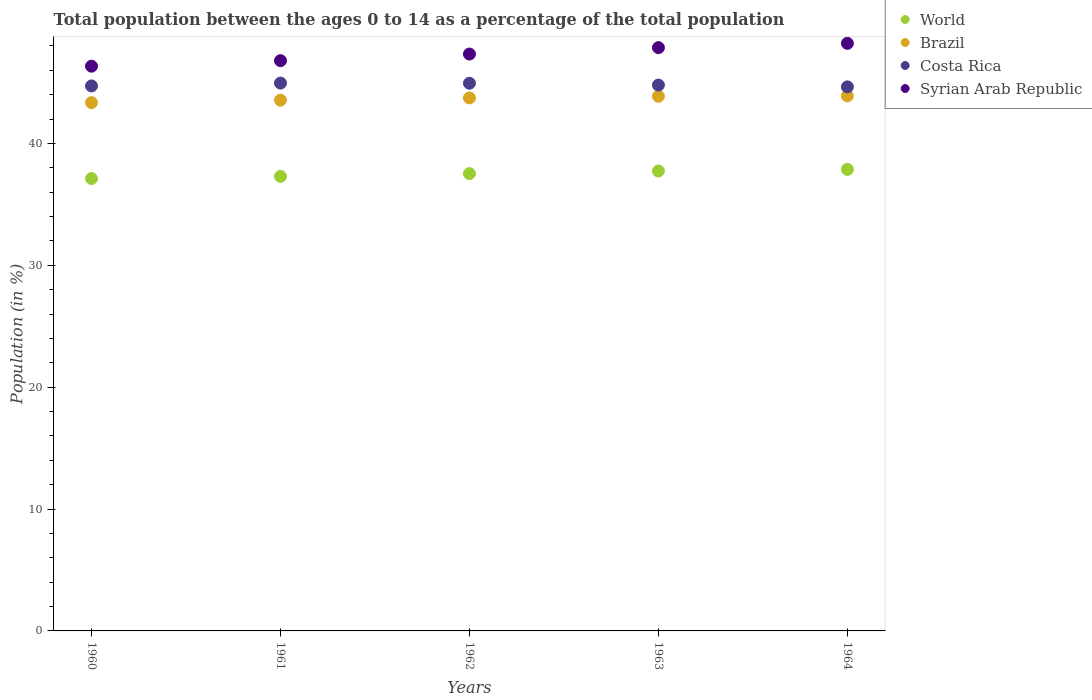What is the percentage of the population ages 0 to 14 in Costa Rica in 1961?
Your answer should be compact. 44.95. Across all years, what is the maximum percentage of the population ages 0 to 14 in Costa Rica?
Keep it short and to the point. 44.95. Across all years, what is the minimum percentage of the population ages 0 to 14 in Syrian Arab Republic?
Ensure brevity in your answer.  46.34. In which year was the percentage of the population ages 0 to 14 in Costa Rica maximum?
Offer a very short reply. 1961. What is the total percentage of the population ages 0 to 14 in World in the graph?
Your answer should be very brief. 187.57. What is the difference between the percentage of the population ages 0 to 14 in World in 1960 and that in 1964?
Make the answer very short. -0.75. What is the difference between the percentage of the population ages 0 to 14 in Costa Rica in 1961 and the percentage of the population ages 0 to 14 in World in 1964?
Make the answer very short. 7.08. What is the average percentage of the population ages 0 to 14 in Costa Rica per year?
Ensure brevity in your answer.  44.81. In the year 1962, what is the difference between the percentage of the population ages 0 to 14 in Syrian Arab Republic and percentage of the population ages 0 to 14 in Costa Rica?
Your response must be concise. 2.4. What is the ratio of the percentage of the population ages 0 to 14 in Brazil in 1961 to that in 1962?
Offer a terse response. 1. Is the percentage of the population ages 0 to 14 in Costa Rica in 1960 less than that in 1962?
Provide a succinct answer. Yes. What is the difference between the highest and the second highest percentage of the population ages 0 to 14 in Costa Rica?
Your response must be concise. 0.01. What is the difference between the highest and the lowest percentage of the population ages 0 to 14 in World?
Offer a very short reply. 0.75. In how many years, is the percentage of the population ages 0 to 14 in Costa Rica greater than the average percentage of the population ages 0 to 14 in Costa Rica taken over all years?
Provide a short and direct response. 2. Is it the case that in every year, the sum of the percentage of the population ages 0 to 14 in World and percentage of the population ages 0 to 14 in Costa Rica  is greater than the sum of percentage of the population ages 0 to 14 in Brazil and percentage of the population ages 0 to 14 in Syrian Arab Republic?
Offer a very short reply. No. Is it the case that in every year, the sum of the percentage of the population ages 0 to 14 in Syrian Arab Republic and percentage of the population ages 0 to 14 in Costa Rica  is greater than the percentage of the population ages 0 to 14 in World?
Ensure brevity in your answer.  Yes. Does the percentage of the population ages 0 to 14 in World monotonically increase over the years?
Make the answer very short. Yes. Is the percentage of the population ages 0 to 14 in Syrian Arab Republic strictly greater than the percentage of the population ages 0 to 14 in World over the years?
Provide a short and direct response. Yes. How many years are there in the graph?
Ensure brevity in your answer.  5. What is the difference between two consecutive major ticks on the Y-axis?
Your answer should be very brief. 10. How are the legend labels stacked?
Your answer should be compact. Vertical. What is the title of the graph?
Make the answer very short. Total population between the ages 0 to 14 as a percentage of the total population. Does "Macao" appear as one of the legend labels in the graph?
Provide a succinct answer. No. What is the label or title of the X-axis?
Provide a succinct answer. Years. What is the Population (in %) of World in 1960?
Provide a short and direct response. 37.12. What is the Population (in %) of Brazil in 1960?
Give a very brief answer. 43.35. What is the Population (in %) in Costa Rica in 1960?
Make the answer very short. 44.72. What is the Population (in %) of Syrian Arab Republic in 1960?
Offer a very short reply. 46.34. What is the Population (in %) of World in 1961?
Your answer should be very brief. 37.3. What is the Population (in %) in Brazil in 1961?
Keep it short and to the point. 43.55. What is the Population (in %) in Costa Rica in 1961?
Your answer should be very brief. 44.95. What is the Population (in %) in Syrian Arab Republic in 1961?
Keep it short and to the point. 46.79. What is the Population (in %) in World in 1962?
Keep it short and to the point. 37.53. What is the Population (in %) of Brazil in 1962?
Your response must be concise. 43.74. What is the Population (in %) in Costa Rica in 1962?
Your response must be concise. 44.94. What is the Population (in %) of Syrian Arab Republic in 1962?
Provide a short and direct response. 47.34. What is the Population (in %) of World in 1963?
Your answer should be very brief. 37.74. What is the Population (in %) of Brazil in 1963?
Offer a very short reply. 43.87. What is the Population (in %) in Costa Rica in 1963?
Give a very brief answer. 44.79. What is the Population (in %) of Syrian Arab Republic in 1963?
Ensure brevity in your answer.  47.86. What is the Population (in %) of World in 1964?
Offer a very short reply. 37.87. What is the Population (in %) of Brazil in 1964?
Offer a terse response. 43.9. What is the Population (in %) of Costa Rica in 1964?
Offer a terse response. 44.64. What is the Population (in %) of Syrian Arab Republic in 1964?
Your answer should be compact. 48.22. Across all years, what is the maximum Population (in %) in World?
Your answer should be compact. 37.87. Across all years, what is the maximum Population (in %) of Brazil?
Provide a succinct answer. 43.9. Across all years, what is the maximum Population (in %) of Costa Rica?
Your response must be concise. 44.95. Across all years, what is the maximum Population (in %) in Syrian Arab Republic?
Keep it short and to the point. 48.22. Across all years, what is the minimum Population (in %) of World?
Your response must be concise. 37.12. Across all years, what is the minimum Population (in %) of Brazil?
Your answer should be compact. 43.35. Across all years, what is the minimum Population (in %) in Costa Rica?
Your response must be concise. 44.64. Across all years, what is the minimum Population (in %) in Syrian Arab Republic?
Keep it short and to the point. 46.34. What is the total Population (in %) of World in the graph?
Your answer should be compact. 187.57. What is the total Population (in %) of Brazil in the graph?
Your response must be concise. 218.42. What is the total Population (in %) in Costa Rica in the graph?
Your answer should be very brief. 224.05. What is the total Population (in %) in Syrian Arab Republic in the graph?
Ensure brevity in your answer.  236.56. What is the difference between the Population (in %) of World in 1960 and that in 1961?
Ensure brevity in your answer.  -0.18. What is the difference between the Population (in %) of Brazil in 1960 and that in 1961?
Make the answer very short. -0.2. What is the difference between the Population (in %) of Costa Rica in 1960 and that in 1961?
Make the answer very short. -0.23. What is the difference between the Population (in %) in Syrian Arab Republic in 1960 and that in 1961?
Provide a short and direct response. -0.45. What is the difference between the Population (in %) of World in 1960 and that in 1962?
Your answer should be compact. -0.4. What is the difference between the Population (in %) in Brazil in 1960 and that in 1962?
Keep it short and to the point. -0.39. What is the difference between the Population (in %) in Costa Rica in 1960 and that in 1962?
Your answer should be very brief. -0.22. What is the difference between the Population (in %) in Syrian Arab Republic in 1960 and that in 1962?
Your response must be concise. -1. What is the difference between the Population (in %) of World in 1960 and that in 1963?
Make the answer very short. -0.62. What is the difference between the Population (in %) in Brazil in 1960 and that in 1963?
Ensure brevity in your answer.  -0.52. What is the difference between the Population (in %) in Costa Rica in 1960 and that in 1963?
Your answer should be compact. -0.07. What is the difference between the Population (in %) in Syrian Arab Republic in 1960 and that in 1963?
Provide a short and direct response. -1.52. What is the difference between the Population (in %) in World in 1960 and that in 1964?
Keep it short and to the point. -0.75. What is the difference between the Population (in %) in Brazil in 1960 and that in 1964?
Offer a terse response. -0.55. What is the difference between the Population (in %) of Costa Rica in 1960 and that in 1964?
Give a very brief answer. 0.08. What is the difference between the Population (in %) in Syrian Arab Republic in 1960 and that in 1964?
Your answer should be very brief. -1.87. What is the difference between the Population (in %) in World in 1961 and that in 1962?
Your answer should be very brief. -0.22. What is the difference between the Population (in %) of Brazil in 1961 and that in 1962?
Provide a succinct answer. -0.19. What is the difference between the Population (in %) in Costa Rica in 1961 and that in 1962?
Provide a succinct answer. 0.01. What is the difference between the Population (in %) of Syrian Arab Republic in 1961 and that in 1962?
Keep it short and to the point. -0.54. What is the difference between the Population (in %) of World in 1961 and that in 1963?
Keep it short and to the point. -0.44. What is the difference between the Population (in %) in Brazil in 1961 and that in 1963?
Your answer should be very brief. -0.32. What is the difference between the Population (in %) of Costa Rica in 1961 and that in 1963?
Offer a terse response. 0.16. What is the difference between the Population (in %) in Syrian Arab Republic in 1961 and that in 1963?
Your response must be concise. -1.07. What is the difference between the Population (in %) in World in 1961 and that in 1964?
Ensure brevity in your answer.  -0.57. What is the difference between the Population (in %) in Brazil in 1961 and that in 1964?
Ensure brevity in your answer.  -0.35. What is the difference between the Population (in %) of Costa Rica in 1961 and that in 1964?
Your answer should be very brief. 0.31. What is the difference between the Population (in %) of Syrian Arab Republic in 1961 and that in 1964?
Your answer should be very brief. -1.42. What is the difference between the Population (in %) of World in 1962 and that in 1963?
Keep it short and to the point. -0.22. What is the difference between the Population (in %) of Brazil in 1962 and that in 1963?
Keep it short and to the point. -0.13. What is the difference between the Population (in %) in Costa Rica in 1962 and that in 1963?
Make the answer very short. 0.15. What is the difference between the Population (in %) in Syrian Arab Republic in 1962 and that in 1963?
Give a very brief answer. -0.52. What is the difference between the Population (in %) in World in 1962 and that in 1964?
Your response must be concise. -0.35. What is the difference between the Population (in %) of Brazil in 1962 and that in 1964?
Your response must be concise. -0.16. What is the difference between the Population (in %) in Costa Rica in 1962 and that in 1964?
Your answer should be compact. 0.3. What is the difference between the Population (in %) in Syrian Arab Republic in 1962 and that in 1964?
Offer a very short reply. -0.88. What is the difference between the Population (in %) of World in 1963 and that in 1964?
Your response must be concise. -0.13. What is the difference between the Population (in %) of Brazil in 1963 and that in 1964?
Your response must be concise. -0.03. What is the difference between the Population (in %) in Costa Rica in 1963 and that in 1964?
Your answer should be very brief. 0.15. What is the difference between the Population (in %) in Syrian Arab Republic in 1963 and that in 1964?
Provide a short and direct response. -0.35. What is the difference between the Population (in %) of World in 1960 and the Population (in %) of Brazil in 1961?
Your answer should be very brief. -6.43. What is the difference between the Population (in %) of World in 1960 and the Population (in %) of Costa Rica in 1961?
Ensure brevity in your answer.  -7.83. What is the difference between the Population (in %) of World in 1960 and the Population (in %) of Syrian Arab Republic in 1961?
Provide a succinct answer. -9.67. What is the difference between the Population (in %) of Brazil in 1960 and the Population (in %) of Costa Rica in 1961?
Provide a short and direct response. -1.6. What is the difference between the Population (in %) in Brazil in 1960 and the Population (in %) in Syrian Arab Republic in 1961?
Provide a succinct answer. -3.44. What is the difference between the Population (in %) in Costa Rica in 1960 and the Population (in %) in Syrian Arab Republic in 1961?
Make the answer very short. -2.07. What is the difference between the Population (in %) of World in 1960 and the Population (in %) of Brazil in 1962?
Your answer should be compact. -6.62. What is the difference between the Population (in %) of World in 1960 and the Population (in %) of Costa Rica in 1962?
Your answer should be compact. -7.82. What is the difference between the Population (in %) in World in 1960 and the Population (in %) in Syrian Arab Republic in 1962?
Give a very brief answer. -10.22. What is the difference between the Population (in %) in Brazil in 1960 and the Population (in %) in Costa Rica in 1962?
Provide a succinct answer. -1.59. What is the difference between the Population (in %) in Brazil in 1960 and the Population (in %) in Syrian Arab Republic in 1962?
Keep it short and to the point. -3.98. What is the difference between the Population (in %) in Costa Rica in 1960 and the Population (in %) in Syrian Arab Republic in 1962?
Ensure brevity in your answer.  -2.62. What is the difference between the Population (in %) of World in 1960 and the Population (in %) of Brazil in 1963?
Provide a short and direct response. -6.75. What is the difference between the Population (in %) of World in 1960 and the Population (in %) of Costa Rica in 1963?
Provide a succinct answer. -7.67. What is the difference between the Population (in %) in World in 1960 and the Population (in %) in Syrian Arab Republic in 1963?
Offer a very short reply. -10.74. What is the difference between the Population (in %) of Brazil in 1960 and the Population (in %) of Costa Rica in 1963?
Provide a succinct answer. -1.44. What is the difference between the Population (in %) of Brazil in 1960 and the Population (in %) of Syrian Arab Republic in 1963?
Keep it short and to the point. -4.51. What is the difference between the Population (in %) in Costa Rica in 1960 and the Population (in %) in Syrian Arab Republic in 1963?
Your response must be concise. -3.14. What is the difference between the Population (in %) in World in 1960 and the Population (in %) in Brazil in 1964?
Offer a terse response. -6.78. What is the difference between the Population (in %) in World in 1960 and the Population (in %) in Costa Rica in 1964?
Provide a succinct answer. -7.52. What is the difference between the Population (in %) in World in 1960 and the Population (in %) in Syrian Arab Republic in 1964?
Offer a terse response. -11.1. What is the difference between the Population (in %) of Brazil in 1960 and the Population (in %) of Costa Rica in 1964?
Provide a short and direct response. -1.29. What is the difference between the Population (in %) in Brazil in 1960 and the Population (in %) in Syrian Arab Republic in 1964?
Offer a very short reply. -4.86. What is the difference between the Population (in %) in Costa Rica in 1960 and the Population (in %) in Syrian Arab Republic in 1964?
Give a very brief answer. -3.5. What is the difference between the Population (in %) in World in 1961 and the Population (in %) in Brazil in 1962?
Offer a terse response. -6.44. What is the difference between the Population (in %) in World in 1961 and the Population (in %) in Costa Rica in 1962?
Ensure brevity in your answer.  -7.64. What is the difference between the Population (in %) in World in 1961 and the Population (in %) in Syrian Arab Republic in 1962?
Provide a short and direct response. -10.04. What is the difference between the Population (in %) of Brazil in 1961 and the Population (in %) of Costa Rica in 1962?
Your answer should be compact. -1.39. What is the difference between the Population (in %) in Brazil in 1961 and the Population (in %) in Syrian Arab Republic in 1962?
Ensure brevity in your answer.  -3.78. What is the difference between the Population (in %) in Costa Rica in 1961 and the Population (in %) in Syrian Arab Republic in 1962?
Your response must be concise. -2.38. What is the difference between the Population (in %) of World in 1961 and the Population (in %) of Brazil in 1963?
Your response must be concise. -6.57. What is the difference between the Population (in %) of World in 1961 and the Population (in %) of Costa Rica in 1963?
Provide a short and direct response. -7.49. What is the difference between the Population (in %) of World in 1961 and the Population (in %) of Syrian Arab Republic in 1963?
Your answer should be very brief. -10.56. What is the difference between the Population (in %) in Brazil in 1961 and the Population (in %) in Costa Rica in 1963?
Make the answer very short. -1.24. What is the difference between the Population (in %) in Brazil in 1961 and the Population (in %) in Syrian Arab Republic in 1963?
Offer a very short reply. -4.31. What is the difference between the Population (in %) in Costa Rica in 1961 and the Population (in %) in Syrian Arab Republic in 1963?
Give a very brief answer. -2.91. What is the difference between the Population (in %) in World in 1961 and the Population (in %) in Brazil in 1964?
Ensure brevity in your answer.  -6.6. What is the difference between the Population (in %) in World in 1961 and the Population (in %) in Costa Rica in 1964?
Provide a short and direct response. -7.34. What is the difference between the Population (in %) in World in 1961 and the Population (in %) in Syrian Arab Republic in 1964?
Provide a succinct answer. -10.92. What is the difference between the Population (in %) in Brazil in 1961 and the Population (in %) in Costa Rica in 1964?
Keep it short and to the point. -1.09. What is the difference between the Population (in %) in Brazil in 1961 and the Population (in %) in Syrian Arab Republic in 1964?
Your response must be concise. -4.66. What is the difference between the Population (in %) in Costa Rica in 1961 and the Population (in %) in Syrian Arab Republic in 1964?
Keep it short and to the point. -3.26. What is the difference between the Population (in %) in World in 1962 and the Population (in %) in Brazil in 1963?
Make the answer very short. -6.35. What is the difference between the Population (in %) in World in 1962 and the Population (in %) in Costa Rica in 1963?
Make the answer very short. -7.27. What is the difference between the Population (in %) in World in 1962 and the Population (in %) in Syrian Arab Republic in 1963?
Keep it short and to the point. -10.34. What is the difference between the Population (in %) of Brazil in 1962 and the Population (in %) of Costa Rica in 1963?
Give a very brief answer. -1.05. What is the difference between the Population (in %) of Brazil in 1962 and the Population (in %) of Syrian Arab Republic in 1963?
Provide a short and direct response. -4.12. What is the difference between the Population (in %) of Costa Rica in 1962 and the Population (in %) of Syrian Arab Republic in 1963?
Your response must be concise. -2.92. What is the difference between the Population (in %) in World in 1962 and the Population (in %) in Brazil in 1964?
Offer a terse response. -6.38. What is the difference between the Population (in %) in World in 1962 and the Population (in %) in Costa Rica in 1964?
Your answer should be very brief. -7.12. What is the difference between the Population (in %) of World in 1962 and the Population (in %) of Syrian Arab Republic in 1964?
Ensure brevity in your answer.  -10.69. What is the difference between the Population (in %) of Brazil in 1962 and the Population (in %) of Costa Rica in 1964?
Keep it short and to the point. -0.9. What is the difference between the Population (in %) of Brazil in 1962 and the Population (in %) of Syrian Arab Republic in 1964?
Your answer should be very brief. -4.48. What is the difference between the Population (in %) in Costa Rica in 1962 and the Population (in %) in Syrian Arab Republic in 1964?
Make the answer very short. -3.28. What is the difference between the Population (in %) of World in 1963 and the Population (in %) of Brazil in 1964?
Make the answer very short. -6.16. What is the difference between the Population (in %) of World in 1963 and the Population (in %) of Costa Rica in 1964?
Give a very brief answer. -6.9. What is the difference between the Population (in %) of World in 1963 and the Population (in %) of Syrian Arab Republic in 1964?
Keep it short and to the point. -10.48. What is the difference between the Population (in %) in Brazil in 1963 and the Population (in %) in Costa Rica in 1964?
Offer a terse response. -0.77. What is the difference between the Population (in %) of Brazil in 1963 and the Population (in %) of Syrian Arab Republic in 1964?
Your answer should be very brief. -4.34. What is the difference between the Population (in %) of Costa Rica in 1963 and the Population (in %) of Syrian Arab Republic in 1964?
Provide a succinct answer. -3.42. What is the average Population (in %) of World per year?
Give a very brief answer. 37.51. What is the average Population (in %) in Brazil per year?
Offer a terse response. 43.68. What is the average Population (in %) of Costa Rica per year?
Offer a very short reply. 44.81. What is the average Population (in %) of Syrian Arab Republic per year?
Your answer should be very brief. 47.31. In the year 1960, what is the difference between the Population (in %) in World and Population (in %) in Brazil?
Your answer should be compact. -6.23. In the year 1960, what is the difference between the Population (in %) in World and Population (in %) in Costa Rica?
Provide a succinct answer. -7.6. In the year 1960, what is the difference between the Population (in %) of World and Population (in %) of Syrian Arab Republic?
Give a very brief answer. -9.22. In the year 1960, what is the difference between the Population (in %) of Brazil and Population (in %) of Costa Rica?
Provide a succinct answer. -1.37. In the year 1960, what is the difference between the Population (in %) in Brazil and Population (in %) in Syrian Arab Republic?
Offer a very short reply. -2.99. In the year 1960, what is the difference between the Population (in %) in Costa Rica and Population (in %) in Syrian Arab Republic?
Offer a terse response. -1.62. In the year 1961, what is the difference between the Population (in %) in World and Population (in %) in Brazil?
Provide a succinct answer. -6.25. In the year 1961, what is the difference between the Population (in %) of World and Population (in %) of Costa Rica?
Provide a succinct answer. -7.65. In the year 1961, what is the difference between the Population (in %) of World and Population (in %) of Syrian Arab Republic?
Provide a succinct answer. -9.49. In the year 1961, what is the difference between the Population (in %) of Brazil and Population (in %) of Costa Rica?
Your answer should be compact. -1.4. In the year 1961, what is the difference between the Population (in %) of Brazil and Population (in %) of Syrian Arab Republic?
Your answer should be very brief. -3.24. In the year 1961, what is the difference between the Population (in %) in Costa Rica and Population (in %) in Syrian Arab Republic?
Offer a terse response. -1.84. In the year 1962, what is the difference between the Population (in %) in World and Population (in %) in Brazil?
Provide a succinct answer. -6.21. In the year 1962, what is the difference between the Population (in %) of World and Population (in %) of Costa Rica?
Offer a very short reply. -7.42. In the year 1962, what is the difference between the Population (in %) of World and Population (in %) of Syrian Arab Republic?
Your answer should be very brief. -9.81. In the year 1962, what is the difference between the Population (in %) in Brazil and Population (in %) in Costa Rica?
Give a very brief answer. -1.2. In the year 1962, what is the difference between the Population (in %) in Brazil and Population (in %) in Syrian Arab Republic?
Your answer should be compact. -3.6. In the year 1962, what is the difference between the Population (in %) of Costa Rica and Population (in %) of Syrian Arab Republic?
Make the answer very short. -2.4. In the year 1963, what is the difference between the Population (in %) in World and Population (in %) in Brazil?
Provide a short and direct response. -6.13. In the year 1963, what is the difference between the Population (in %) in World and Population (in %) in Costa Rica?
Offer a terse response. -7.05. In the year 1963, what is the difference between the Population (in %) in World and Population (in %) in Syrian Arab Republic?
Ensure brevity in your answer.  -10.12. In the year 1963, what is the difference between the Population (in %) in Brazil and Population (in %) in Costa Rica?
Keep it short and to the point. -0.92. In the year 1963, what is the difference between the Population (in %) in Brazil and Population (in %) in Syrian Arab Republic?
Make the answer very short. -3.99. In the year 1963, what is the difference between the Population (in %) of Costa Rica and Population (in %) of Syrian Arab Republic?
Make the answer very short. -3.07. In the year 1964, what is the difference between the Population (in %) of World and Population (in %) of Brazil?
Your answer should be compact. -6.03. In the year 1964, what is the difference between the Population (in %) of World and Population (in %) of Costa Rica?
Your response must be concise. -6.77. In the year 1964, what is the difference between the Population (in %) in World and Population (in %) in Syrian Arab Republic?
Offer a terse response. -10.34. In the year 1964, what is the difference between the Population (in %) in Brazil and Population (in %) in Costa Rica?
Provide a succinct answer. -0.74. In the year 1964, what is the difference between the Population (in %) in Brazil and Population (in %) in Syrian Arab Republic?
Your answer should be compact. -4.32. In the year 1964, what is the difference between the Population (in %) of Costa Rica and Population (in %) of Syrian Arab Republic?
Ensure brevity in your answer.  -3.57. What is the ratio of the Population (in %) of Brazil in 1960 to that in 1961?
Offer a terse response. 1. What is the ratio of the Population (in %) in Syrian Arab Republic in 1960 to that in 1961?
Keep it short and to the point. 0.99. What is the ratio of the Population (in %) in World in 1960 to that in 1962?
Make the answer very short. 0.99. What is the ratio of the Population (in %) in Brazil in 1960 to that in 1962?
Offer a very short reply. 0.99. What is the ratio of the Population (in %) of World in 1960 to that in 1963?
Your answer should be very brief. 0.98. What is the ratio of the Population (in %) of Costa Rica in 1960 to that in 1963?
Keep it short and to the point. 1. What is the ratio of the Population (in %) of Syrian Arab Republic in 1960 to that in 1963?
Ensure brevity in your answer.  0.97. What is the ratio of the Population (in %) of World in 1960 to that in 1964?
Provide a short and direct response. 0.98. What is the ratio of the Population (in %) in Brazil in 1960 to that in 1964?
Make the answer very short. 0.99. What is the ratio of the Population (in %) of Syrian Arab Republic in 1960 to that in 1964?
Your answer should be compact. 0.96. What is the ratio of the Population (in %) of Brazil in 1961 to that in 1962?
Offer a terse response. 1. What is the ratio of the Population (in %) of World in 1961 to that in 1963?
Ensure brevity in your answer.  0.99. What is the ratio of the Population (in %) of Syrian Arab Republic in 1961 to that in 1963?
Give a very brief answer. 0.98. What is the ratio of the Population (in %) of World in 1961 to that in 1964?
Keep it short and to the point. 0.98. What is the ratio of the Population (in %) of Syrian Arab Republic in 1961 to that in 1964?
Make the answer very short. 0.97. What is the ratio of the Population (in %) of World in 1962 to that in 1963?
Your answer should be compact. 0.99. What is the ratio of the Population (in %) of Costa Rica in 1962 to that in 1963?
Offer a terse response. 1. What is the ratio of the Population (in %) of World in 1962 to that in 1964?
Keep it short and to the point. 0.99. What is the ratio of the Population (in %) in Syrian Arab Republic in 1962 to that in 1964?
Your response must be concise. 0.98. What is the difference between the highest and the second highest Population (in %) in World?
Your answer should be very brief. 0.13. What is the difference between the highest and the second highest Population (in %) of Brazil?
Offer a terse response. 0.03. What is the difference between the highest and the second highest Population (in %) of Costa Rica?
Give a very brief answer. 0.01. What is the difference between the highest and the second highest Population (in %) in Syrian Arab Republic?
Give a very brief answer. 0.35. What is the difference between the highest and the lowest Population (in %) in World?
Your answer should be compact. 0.75. What is the difference between the highest and the lowest Population (in %) of Brazil?
Ensure brevity in your answer.  0.55. What is the difference between the highest and the lowest Population (in %) of Costa Rica?
Provide a short and direct response. 0.31. What is the difference between the highest and the lowest Population (in %) of Syrian Arab Republic?
Keep it short and to the point. 1.87. 